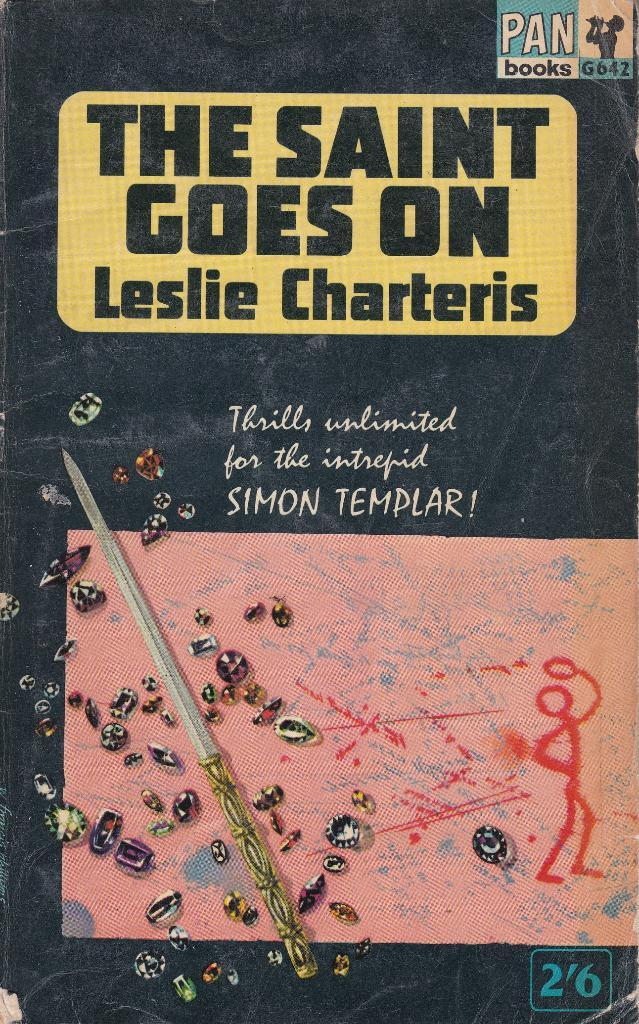<image>
Relay a brief, clear account of the picture shown. The cover to a book with the title The Saint Goes On. 